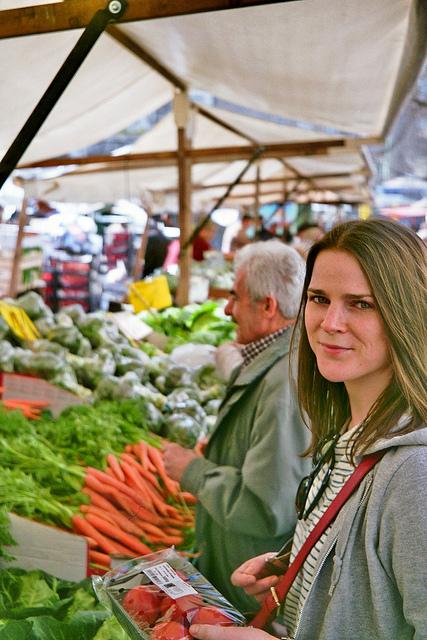Would you purchase ingredients for a salad here?
Be succinct. Yes. What is being sold?
Answer briefly. Vegetables. What is above the woman's head?
Quick response, please. Umbrella. Is the woman happy?
Write a very short answer. Yes. Is this in America?
Quick response, please. Yes. Who has a striped shirt?
Concise answer only. Woman. Is the man in the foreground sitting?
Be succinct. No. 